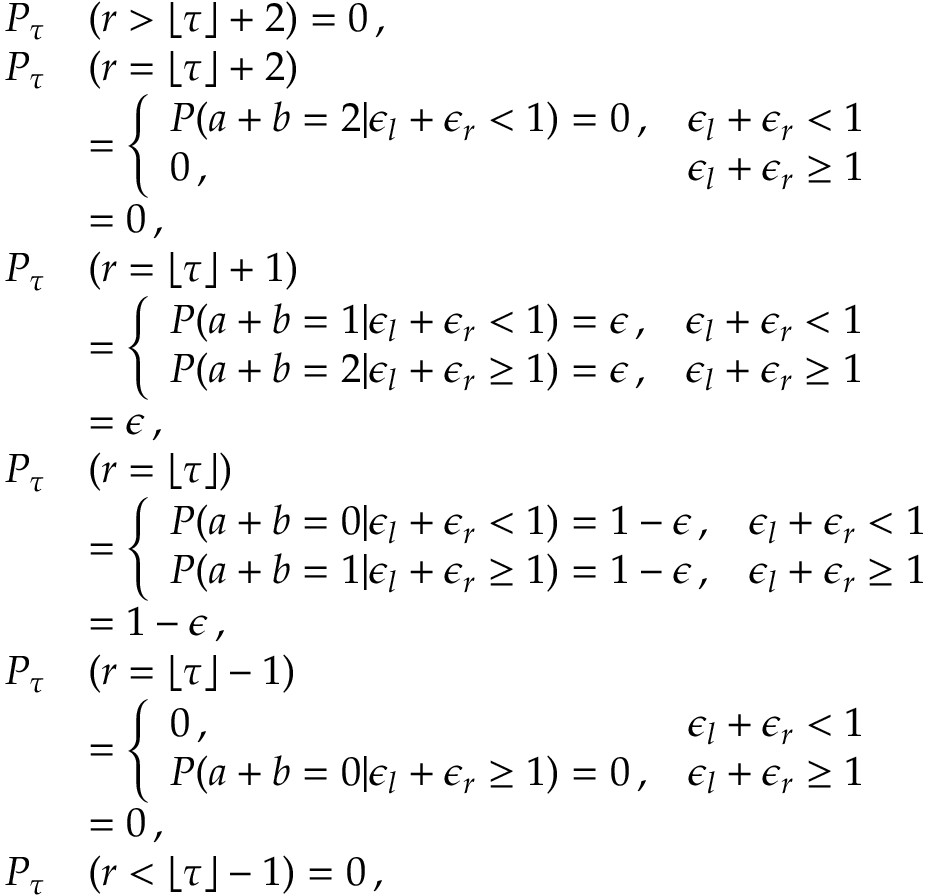Convert formula to latex. <formula><loc_0><loc_0><loc_500><loc_500>\begin{array} { r l } { P _ { \tau } } & { ( r > \lfloor \tau \rfloor + 2 ) = 0 \, , } \\ { P _ { \tau } } & { ( r = \lfloor \tau \rfloor + 2 ) } \\ & { = \left \{ \begin{array} { l l } { P ( a + b = 2 | \epsilon _ { l } + \epsilon _ { r } < 1 ) = 0 \, , } & { \epsilon _ { l } + \epsilon _ { r } < 1 } \\ { 0 \, , } & { \epsilon _ { l } + \epsilon _ { r } \geq 1 } \end{array} } \\ & { = 0 \, , } \\ { P _ { \tau } } & { ( r = \lfloor \tau \rfloor + 1 ) } \\ & { = \left \{ \begin{array} { l l } { P ( a + b = 1 | \epsilon _ { l } + \epsilon _ { r } < 1 ) = \epsilon \, , } & { \epsilon _ { l } + \epsilon _ { r } < 1 } \\ { P ( a + b = 2 | \epsilon _ { l } + \epsilon _ { r } \geq 1 ) = \epsilon \, , } & { \epsilon _ { l } + \epsilon _ { r } \geq 1 } \end{array} } \\ & { = \epsilon \, , } \\ { P _ { \tau } } & { ( r = \lfloor \tau \rfloor ) } \\ & { = \left \{ \begin{array} { l l } { P ( a + b = 0 | \epsilon _ { l } + \epsilon _ { r } < 1 ) = 1 - \epsilon \, , } & { \epsilon _ { l } + \epsilon _ { r } < 1 } \\ { P ( a + b = 1 | \epsilon _ { l } + \epsilon _ { r } \geq 1 ) = 1 - \epsilon \, , } & { \epsilon _ { l } + \epsilon _ { r } \geq 1 } \end{array} } \\ & { = 1 - \epsilon \, , } \\ { P _ { \tau } } & { ( r = \lfloor \tau \rfloor - 1 ) } \\ & { = \left \{ \begin{array} { l l } { 0 \, , } & { \epsilon _ { l } + \epsilon _ { r } < 1 } \\ { P ( a + b = 0 | \epsilon _ { l } + \epsilon _ { r } \geq 1 ) = 0 \, , } & { \epsilon _ { l } + \epsilon _ { r } \geq 1 } \end{array} } \\ & { = 0 \, , } \\ { P _ { \tau } } & { ( r < \lfloor \tau \rfloor - 1 ) = 0 \, , } \end{array}</formula> 